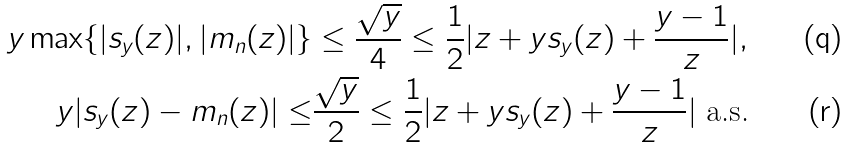Convert formula to latex. <formula><loc_0><loc_0><loc_500><loc_500>y \max \{ | s _ { y } ( z ) | , | m _ { n } ( z ) | \} & \leq \frac { \sqrt { y } } { 4 } \leq \frac { 1 } { 2 } | z + y s _ { y } ( z ) + \frac { y - 1 } z | , \\ y | s _ { y } ( z ) - m _ { n } ( z ) | \leq & \frac { \sqrt { y } } 2 \leq \frac { 1 } { 2 } | z + y s _ { y } ( z ) + \frac { y - 1 } z | \text { a.s.}</formula> 